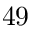<formula> <loc_0><loc_0><loc_500><loc_500>^ { 4 } 9</formula> 